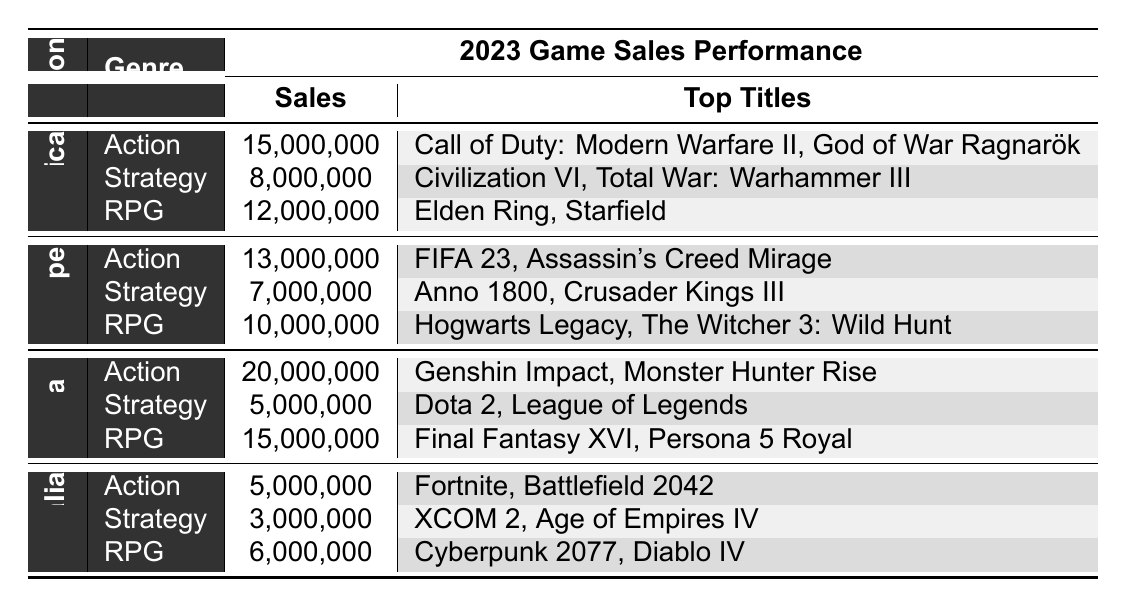What is the total sales for Action games in North America? According to the table, the sales for Action games in North America is listed as 15,000,000.
Answer: 15,000,000 Which region had the highest sales for RPG games in 2023? By examining the sales figures, North America had 12,000,000, Europe had 10,000,000, Asia had 15,000,000, and Australia had 6,000,000. Asia has the highest sales at 15,000,000.
Answer: Asia How many total sales were made for Strategy games across all regions? The total sales for Strategy games are summed up as follows: North America (8,000,000) + Europe (7,000,000) + Asia (5,000,000) + Australia (3,000,000) = 23,000,000.
Answer: 23,000,000 Is the total sales of Action games in Asia greater than the total sales of RPG games in Europe? The total sales for Action games in Asia is 20,000,000, while the total sales for RPG games in Europe is 10,000,000. Since 20,000,000 is greater than 10,000,000, the statement is true.
Answer: Yes What is the average sales figure for RPG games across all regions? The sales figures for RPG games across all regions are: North America (12,000,000), Europe (10,000,000), Asia (15,000,000), and Australia (6,000,000). Summing these gives 12,000,000 + 10,000,000 + 15,000,000 + 6,000,000 = 43,000,000. There are 4 regions, so the average is 43,000,000 / 4 = 10,750,000.
Answer: 10,750,000 Which genre had the lowest sales in Australia, and what was the amount? Looking at the table, the sales for Action games in Australia were 5,000,000, Strategy games were 3,000,000, and RPG games were 6,000,000. The lowest sales are for Strategy games at 3,000,000.
Answer: Strategy with 3,000,000 How much more did Asia sell in Action games compared to North America? The sales for Action games in Asia is 20,000,000, whereas North America sold 15,000,000. The difference is 20,000,000 - 15,000,000 = 5,000,000, indicating Asia sold 5,000,000 more in Action games.
Answer: 5,000,000 Which region had better sales performance in Strategy games than in Action games in 2023? Evaluating each region: North America (Strategy: 8,000,000 vs. Action: 15,000,000), Europe (Strategy: 7,000,000 vs. Action: 13,000,000), Asia (Strategy: 5,000,000 vs. Action: 20,000,000), and Australia (Strategy: 3,000,000 vs. Action: 5,000,000). None had better sales in Strategy compared to Action, so the answer is none of the regions.
Answer: None What is the total sales of games in Europe for all genres combined? The sales figures for Europe are: Action (13,000,000), Strategy (7,000,000), and RPG (10,000,000). Adding these gives 13,000,000 + 7,000,000 + 10,000,000 = 30,000,000 for the total sales in Europe.
Answer: 30,000,000 Considering all regions, which genre had the highest overall sales performance? Checking the total sales by genre across all regions, Action: 15,000,000 + 13,000,000 + 20,000,000 + 5,000,000 = 53,000,000, Strategy: 8,000,000 + 7,000,000 + 5,000,000 + 3,000,000 = 23,000,000, RPG: 12,000,000 + 10,000,000 + 15,000,000 + 6,000,000 = 43,000,000. Therefore, Action games had the highest sales performance overall at 53,000,000.
Answer: Action 